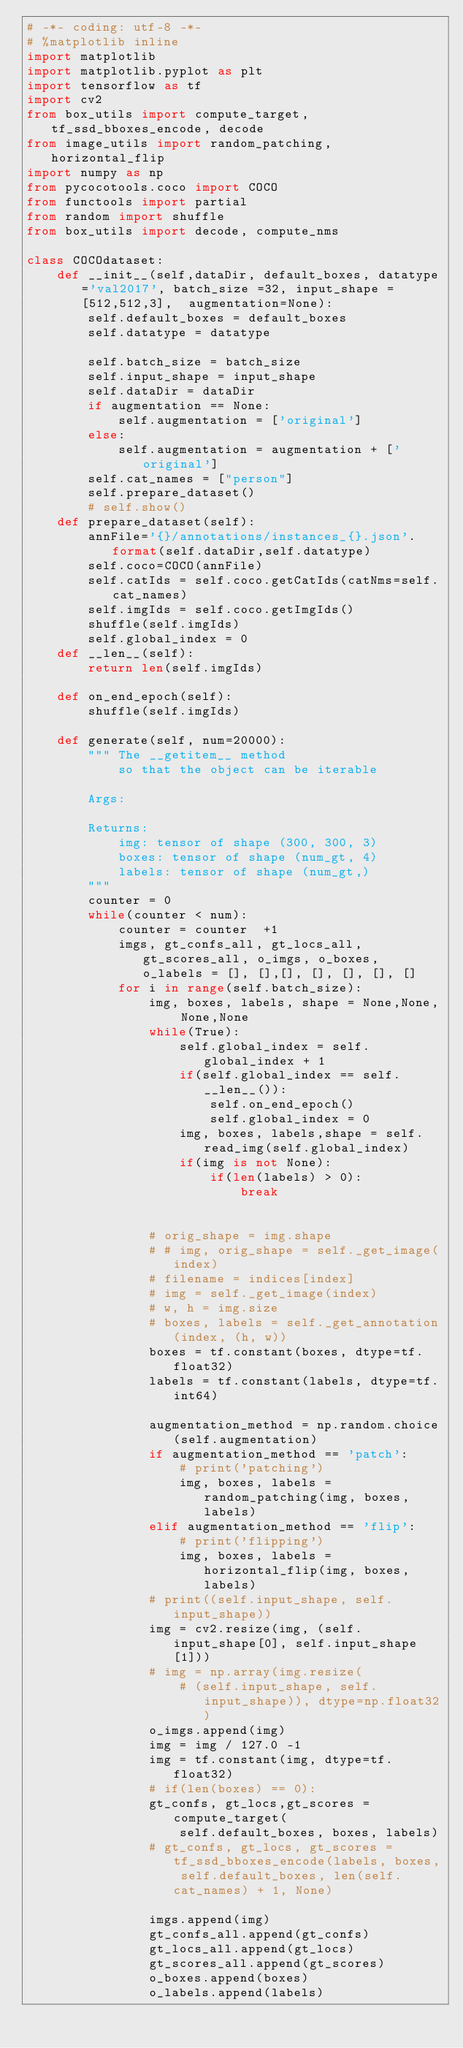<code> <loc_0><loc_0><loc_500><loc_500><_Python_># -*- coding: utf-8 -*-
# %matplotlib inline
import matplotlib
import matplotlib.pyplot as plt
import tensorflow as tf
import cv2
from box_utils import compute_target, tf_ssd_bboxes_encode, decode
from image_utils import random_patching, horizontal_flip
import numpy as np
from pycocotools.coco import COCO
from functools import partial
from random import shuffle
from box_utils import decode, compute_nms

class COCOdataset:
    def __init__(self,dataDir, default_boxes, datatype='val2017', batch_size =32, input_shape = [512,512,3],  augmentation=None):
        self.default_boxes = default_boxes
        self.datatype = datatype   
        
        self.batch_size = batch_size
        self.input_shape = input_shape
        self.dataDir = dataDir
        if augmentation == None:
            self.augmentation = ['original']
        else:
            self.augmentation = augmentation + ['original']
        self.cat_names = ["person"]
        self.prepare_dataset()
        # self.show()
    def prepare_dataset(self):
        annFile='{}/annotations/instances_{}.json'.format(self.dataDir,self.datatype)
        self.coco=COCO(annFile)
        self.catIds = self.coco.getCatIds(catNms=self.cat_names)
        self.imgIds = self.coco.getImgIds()
        shuffle(self.imgIds)
        self.global_index = 0
    def __len__(self):
        return len(self.imgIds)
    
    def on_end_epoch(self):
        shuffle(self.imgIds)

    def generate(self, num=20000):
        """ The __getitem__ method
            so that the object can be iterable

        Args:

        Returns:
            img: tensor of shape (300, 300, 3)
            boxes: tensor of shape (num_gt, 4)
            labels: tensor of shape (num_gt,)
        """
        counter = 0
        while(counter < num):  
            counter = counter  +1
            imgs, gt_confs_all, gt_locs_all,gt_scores_all, o_imgs, o_boxes, o_labels = [], [],[], [], [], [], []
            for i in range(self.batch_size):                
                img, boxes, labels, shape = None,None, None,None
                while(True):
                    self.global_index = self.global_index + 1
                    if(self.global_index == self.__len__()):
                        self.on_end_epoch()
                        self.global_index = 0
                    img, boxes, labels,shape = self.read_img(self.global_index)
                    if(img is not None):
                        if(len(labels) > 0):
                            break
                    
                  
                # orig_shape = img.shape
                # # img, orig_shape = self._get_image(index)
                # filename = indices[index]
                # img = self._get_image(index)
                # w, h = img.size
                # boxes, labels = self._get_annotation(index, (h, w))
                boxes = tf.constant(boxes, dtype=tf.float32)
                labels = tf.constant(labels, dtype=tf.int64)
    
                augmentation_method = np.random.choice(self.augmentation)
                if augmentation_method == 'patch':
                    # print('patching')
                    img, boxes, labels = random_patching(img, boxes, labels)                    
                elif augmentation_method == 'flip':
                    # print('flipping')
                    img, boxes, labels = horizontal_flip(img, boxes, labels)
                # print((self.input_shape, self.input_shape))
                img = cv2.resize(img, (self.input_shape[0], self.input_shape[1]))
                # img = np.array(img.resize(
                    # (self.input_shape, self.input_shape)), dtype=np.float32)
                o_imgs.append(img)
                img = img / 127.0 -1
                img = tf.constant(img, dtype=tf.float32)
                # if(len(boxes) == 0):
                gt_confs, gt_locs,gt_scores = compute_target(
                    self.default_boxes, boxes, labels)
                # gt_confs, gt_locs, gt_scores = tf_ssd_bboxes_encode(labels, boxes, self.default_boxes, len(self.cat_names) + 1, None)    
                
                imgs.append(img)
                gt_confs_all.append(gt_confs)
                gt_locs_all.append(gt_locs)
                gt_scores_all.append(gt_scores)
                o_boxes.append(boxes)
                o_labels.append(labels)
                </code> 